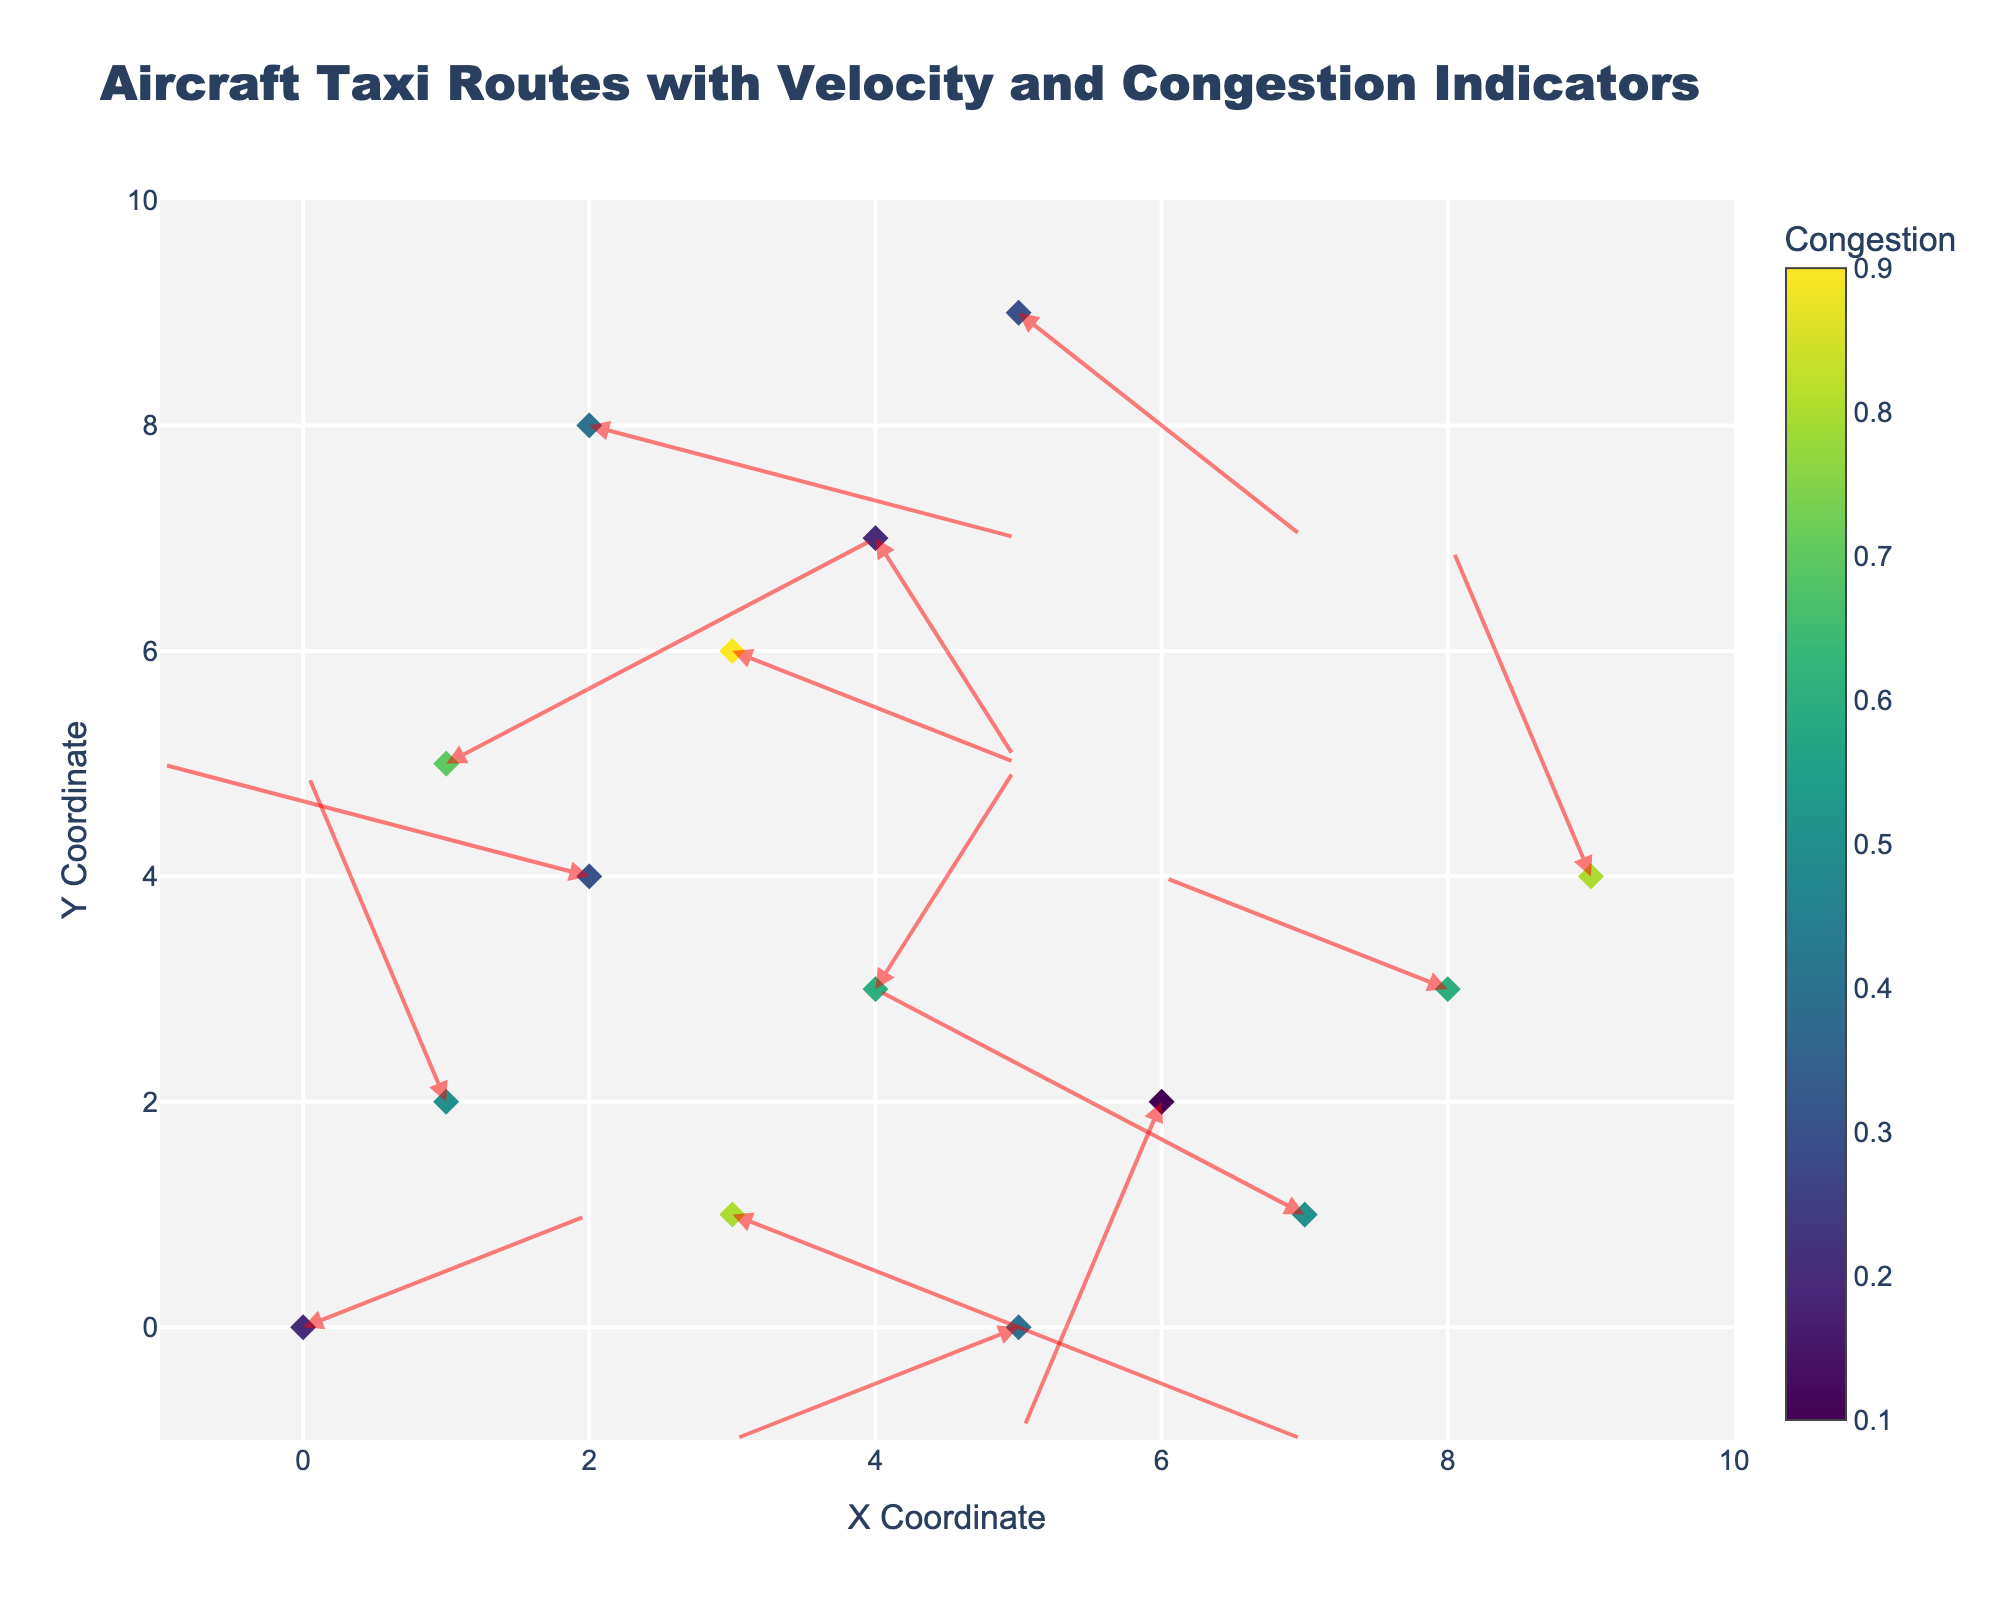What is the title of the figure? The title is displayed at the top of the figure in the largest text. The title reads 'Aircraft Taxi Routes with Velocity and Congestion Indicators'.
Answer: Aircraft Taxi Routes with Velocity and Congestion Indicators Which color scale is used to represent congestion levels? The color scale is shown in the color bar next to the scatter points. The color bar title is 'Congestion', and the gradient ranges from dark purple to yellow, indicating the use of the 'Viridis' color scale.
Answer: Viridis How many points are displayed on the figure? The figure shows one point for each coordinate pair provided in the data table. Counting each pair in the list gives a total of 15 points.
Answer: 15 What is the X and Y coordinate of the point with the highest congestion value? By following the color scale to identify the point with the darkest yellow hue representing high congestion, we find the point at X = 3 and Y = 6 has the highest congestion value of 0.9.
Answer: (3, 6) What is the range of X and Y axes in the figure? The labels on the X and Y axes indicate their range, specified in the code as [−1, 10] for both axes.
Answer: [−1, 10] Which point has the smallest velocity vector? The velocity vector magnitude is calculated as √(u² + v²). Calculating for all points, the smallest vector is (-1, -3) at the point (6, 2), with magnitude √((-1)² + (-3)²) = √10.
Answer: (6, 2) What are the coordinates of the point with the highest congestion after (3,1)? To find this, identify the value and visually inspect points. After (3,1) with congestion 0.8, the next high value after inspection is at (1,5) with congestion 0.7.
Answer: (1,5) Which direction does the point at (5,0) move? By examining the annotation of the arrow starting at (5,0), it moves left and down, determined by u=-2, v=-1; this indicates a southwest direction.
Answer: Southwest What is the average congestion level across all points? Summing congestion values: 0.2 + 0.5 + 0.8 + 0.3 + 0.6 + 0.4 + 0.7 + 0.1 + 0.9 + 0.5 + 0.2 + 0.6 + 0.4 + 0.8 + 0.3 = 7.3. Since there are 15 points, the average congestion is 7.3/15 = 0.4867
Answer: 0.4867 Which points have an upward velocity component? Points having positive v-values represent upward movement. Visual inspection shows points (1,2), (4,3), (1,5), and (9,4) have v > 0.
Answer: (1,2), (4,3), (1,5), (9,4) 